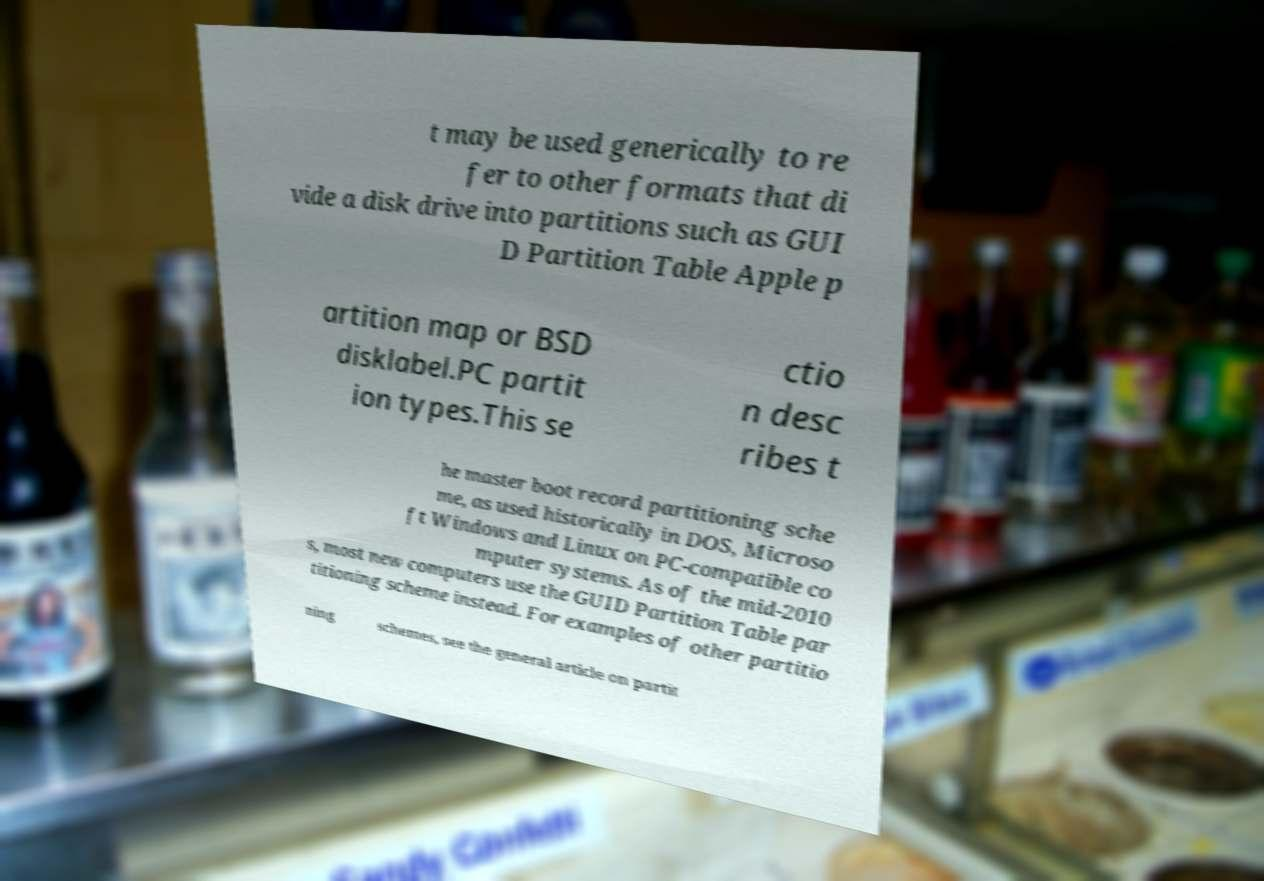Could you assist in decoding the text presented in this image and type it out clearly? t may be used generically to re fer to other formats that di vide a disk drive into partitions such as GUI D Partition Table Apple p artition map or BSD disklabel.PC partit ion types.This se ctio n desc ribes t he master boot record partitioning sche me, as used historically in DOS, Microso ft Windows and Linux on PC-compatible co mputer systems. As of the mid-2010 s, most new computers use the GUID Partition Table par titioning scheme instead. For examples of other partitio ning schemes, see the general article on partit 